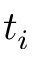Convert formula to latex. <formula><loc_0><loc_0><loc_500><loc_500>t _ { i }</formula> 